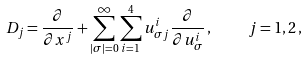Convert formula to latex. <formula><loc_0><loc_0><loc_500><loc_500>D _ { j } = \frac { \partial } { \partial x ^ { j } } + \sum _ { | \sigma | = 0 } ^ { \infty } \sum _ { i = 1 } ^ { 4 } u ^ { i } _ { \sigma j } \frac { \partial } { \partial u ^ { i } _ { \sigma } } \, , \quad j = 1 , 2 \, ,</formula> 